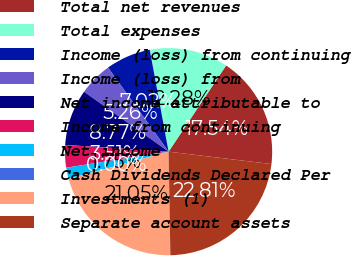Convert chart. <chart><loc_0><loc_0><loc_500><loc_500><pie_chart><fcel>Total net revenues<fcel>Total expenses<fcel>Income (loss) from continuing<fcel>Income (loss) from<fcel>Net income attributable to<fcel>Income from continuing<fcel>Net income<fcel>Cash Dividends Declared Per<fcel>Investments (1)<fcel>Separate account assets<nl><fcel>17.54%<fcel>12.28%<fcel>7.02%<fcel>5.26%<fcel>8.77%<fcel>3.51%<fcel>1.75%<fcel>0.0%<fcel>21.05%<fcel>22.81%<nl></chart> 